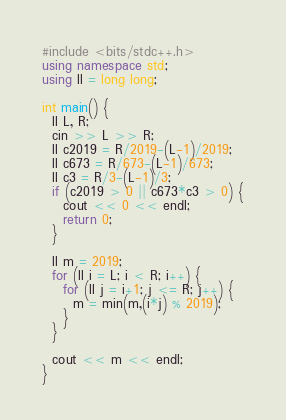Convert code to text. <code><loc_0><loc_0><loc_500><loc_500><_C++_>#include <bits/stdc++.h>
using namespace std;
using ll = long long;

int main() {
  ll L, R;
  cin >> L >> R;
  ll c2019 = R/2019-(L-1)/2019;
  ll c673 = R/673-(L-1)/673;
  ll c3 = R/3-(L-1)/3;
  if (c2019 > 0 || c673*c3 > 0) {
    cout << 0 << endl;
    return 0;
  }
  
  ll m = 2019;
  for (ll i = L; i < R; i++) {
    for (ll j = i+1; j <= R; j++) {
      m = min(m,(i*j) % 2019);
    }
  }
  
  cout << m << endl;
}</code> 